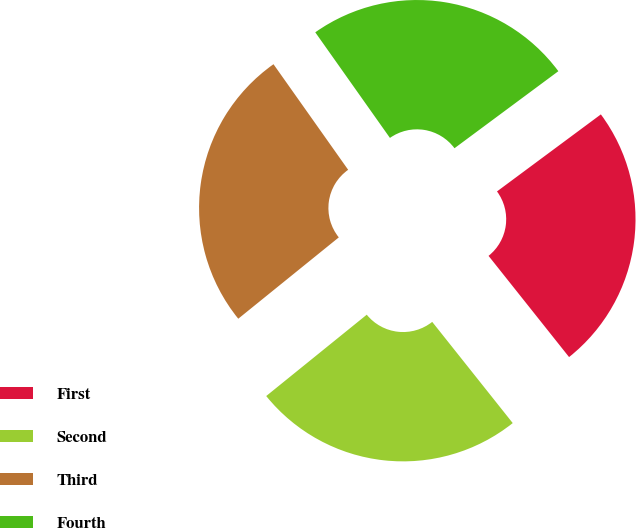Convert chart to OTSL. <chart><loc_0><loc_0><loc_500><loc_500><pie_chart><fcel>First<fcel>Second<fcel>Third<fcel>Fourth<nl><fcel>24.46%<fcel>24.87%<fcel>26.03%<fcel>24.64%<nl></chart> 